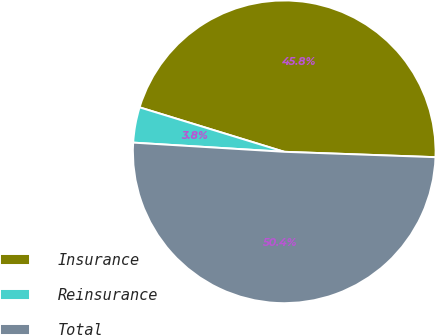<chart> <loc_0><loc_0><loc_500><loc_500><pie_chart><fcel>Insurance<fcel>Reinsurance<fcel>Total<nl><fcel>45.82%<fcel>3.78%<fcel>50.4%<nl></chart> 